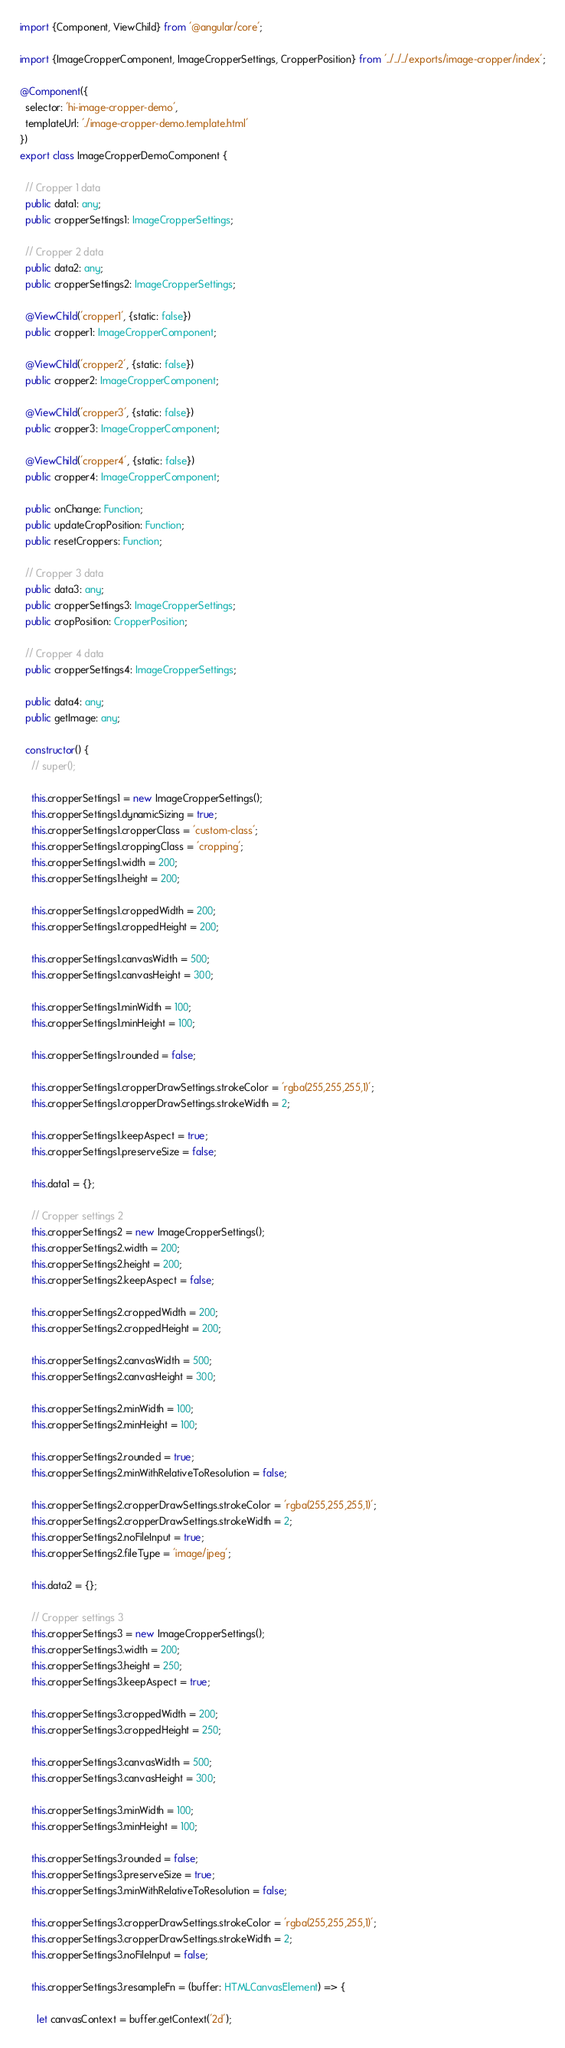Convert code to text. <code><loc_0><loc_0><loc_500><loc_500><_TypeScript_>import {Component, ViewChild} from '@angular/core';

import {ImageCropperComponent, ImageCropperSettings, CropperPosition} from '../../../exports/image-cropper/index';

@Component({
  selector: 'hi-image-cropper-demo',
  templateUrl: './image-cropper-demo.template.html'
})
export class ImageCropperDemoComponent {

  // Cropper 1 data
  public data1: any;
  public cropperSettings1: ImageCropperSettings;

  // Cropper 2 data
  public data2: any;
  public cropperSettings2: ImageCropperSettings;

  @ViewChild('cropper1', {static: false})
  public cropper1: ImageCropperComponent;

  @ViewChild('cropper2', {static: false})
  public cropper2: ImageCropperComponent;

  @ViewChild('cropper3', {static: false})
  public cropper3: ImageCropperComponent;

  @ViewChild('cropper4', {static: false})
  public cropper4: ImageCropperComponent;

  public onChange: Function;
  public updateCropPosition: Function;
  public resetCroppers: Function;

  // Cropper 3 data
  public data3: any;
  public cropperSettings3: ImageCropperSettings;
  public cropPosition: CropperPosition;

  // Cropper 4 data
  public cropperSettings4: ImageCropperSettings;

  public data4: any;
  public getImage: any;

  constructor() {
    // super();

    this.cropperSettings1 = new ImageCropperSettings();
    this.cropperSettings1.dynamicSizing = true;
    this.cropperSettings1.cropperClass = 'custom-class';
    this.cropperSettings1.croppingClass = 'cropping';
    this.cropperSettings1.width = 200;
    this.cropperSettings1.height = 200;

    this.cropperSettings1.croppedWidth = 200;
    this.cropperSettings1.croppedHeight = 200;

    this.cropperSettings1.canvasWidth = 500;
    this.cropperSettings1.canvasHeight = 300;

    this.cropperSettings1.minWidth = 100;
    this.cropperSettings1.minHeight = 100;

    this.cropperSettings1.rounded = false;

    this.cropperSettings1.cropperDrawSettings.strokeColor = 'rgba(255,255,255,1)';
    this.cropperSettings1.cropperDrawSettings.strokeWidth = 2;

    this.cropperSettings1.keepAspect = true;
    this.cropperSettings1.preserveSize = false;

    this.data1 = {};

    // Cropper settings 2
    this.cropperSettings2 = new ImageCropperSettings();
    this.cropperSettings2.width = 200;
    this.cropperSettings2.height = 200;
    this.cropperSettings2.keepAspect = false;

    this.cropperSettings2.croppedWidth = 200;
    this.cropperSettings2.croppedHeight = 200;

    this.cropperSettings2.canvasWidth = 500;
    this.cropperSettings2.canvasHeight = 300;

    this.cropperSettings2.minWidth = 100;
    this.cropperSettings2.minHeight = 100;

    this.cropperSettings2.rounded = true;
    this.cropperSettings2.minWithRelativeToResolution = false;

    this.cropperSettings2.cropperDrawSettings.strokeColor = 'rgba(255,255,255,1)';
    this.cropperSettings2.cropperDrawSettings.strokeWidth = 2;
    this.cropperSettings2.noFileInput = true;
    this.cropperSettings2.fileType = 'image/jpeg';

    this.data2 = {};

    // Cropper settings 3
    this.cropperSettings3 = new ImageCropperSettings();
    this.cropperSettings3.width = 200;
    this.cropperSettings3.height = 250;
    this.cropperSettings3.keepAspect = true;

    this.cropperSettings3.croppedWidth = 200;
    this.cropperSettings3.croppedHeight = 250;

    this.cropperSettings3.canvasWidth = 500;
    this.cropperSettings3.canvasHeight = 300;

    this.cropperSettings3.minWidth = 100;
    this.cropperSettings3.minHeight = 100;

    this.cropperSettings3.rounded = false;
    this.cropperSettings3.preserveSize = true;
    this.cropperSettings3.minWithRelativeToResolution = false;

    this.cropperSettings3.cropperDrawSettings.strokeColor = 'rgba(255,255,255,1)';
    this.cropperSettings3.cropperDrawSettings.strokeWidth = 2;
    this.cropperSettings3.noFileInput = false;

    this.cropperSettings3.resampleFn = (buffer: HTMLCanvasElement) => {

      let canvasContext = buffer.getContext('2d');</code> 